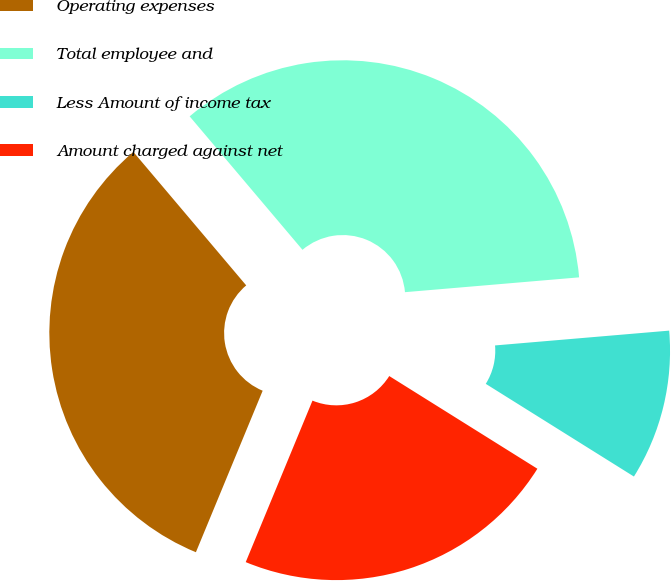Convert chart. <chart><loc_0><loc_0><loc_500><loc_500><pie_chart><fcel>Operating expenses<fcel>Total employee and<fcel>Less Amount of income tax<fcel>Amount charged against net<nl><fcel>32.59%<fcel>34.82%<fcel>10.25%<fcel>22.34%<nl></chart> 